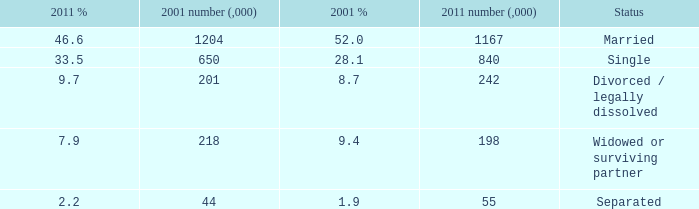How many 2011 % is 7.9? 1.0. 